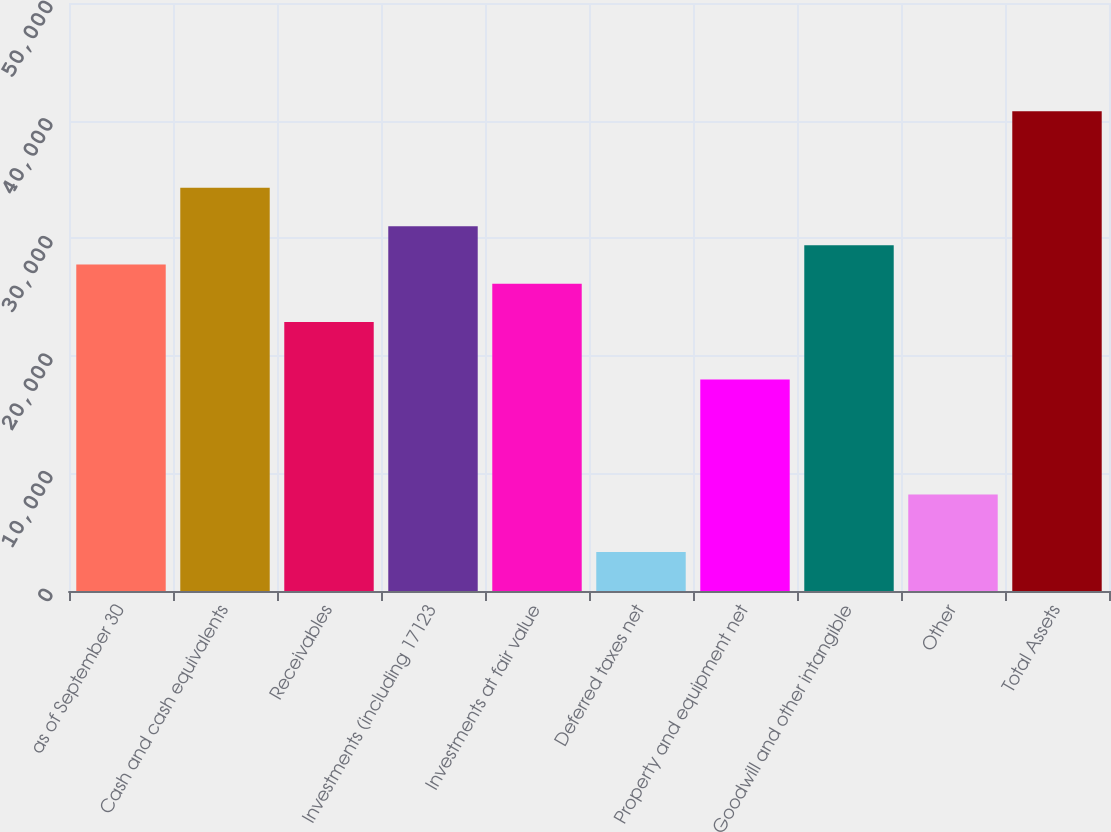Convert chart. <chart><loc_0><loc_0><loc_500><loc_500><bar_chart><fcel>as of September 30<fcel>Cash and cash equivalents<fcel>Receivables<fcel>Investments (including 17123<fcel>Investments at fair value<fcel>Deferred taxes net<fcel>Property and equipment net<fcel>Goodwill and other intangible<fcel>Other<fcel>Total Assets<nl><fcel>27763.5<fcel>34281.4<fcel>22875<fcel>31022.4<fcel>26134<fcel>3321.26<fcel>17986.6<fcel>29392.9<fcel>8209.7<fcel>40799.3<nl></chart> 